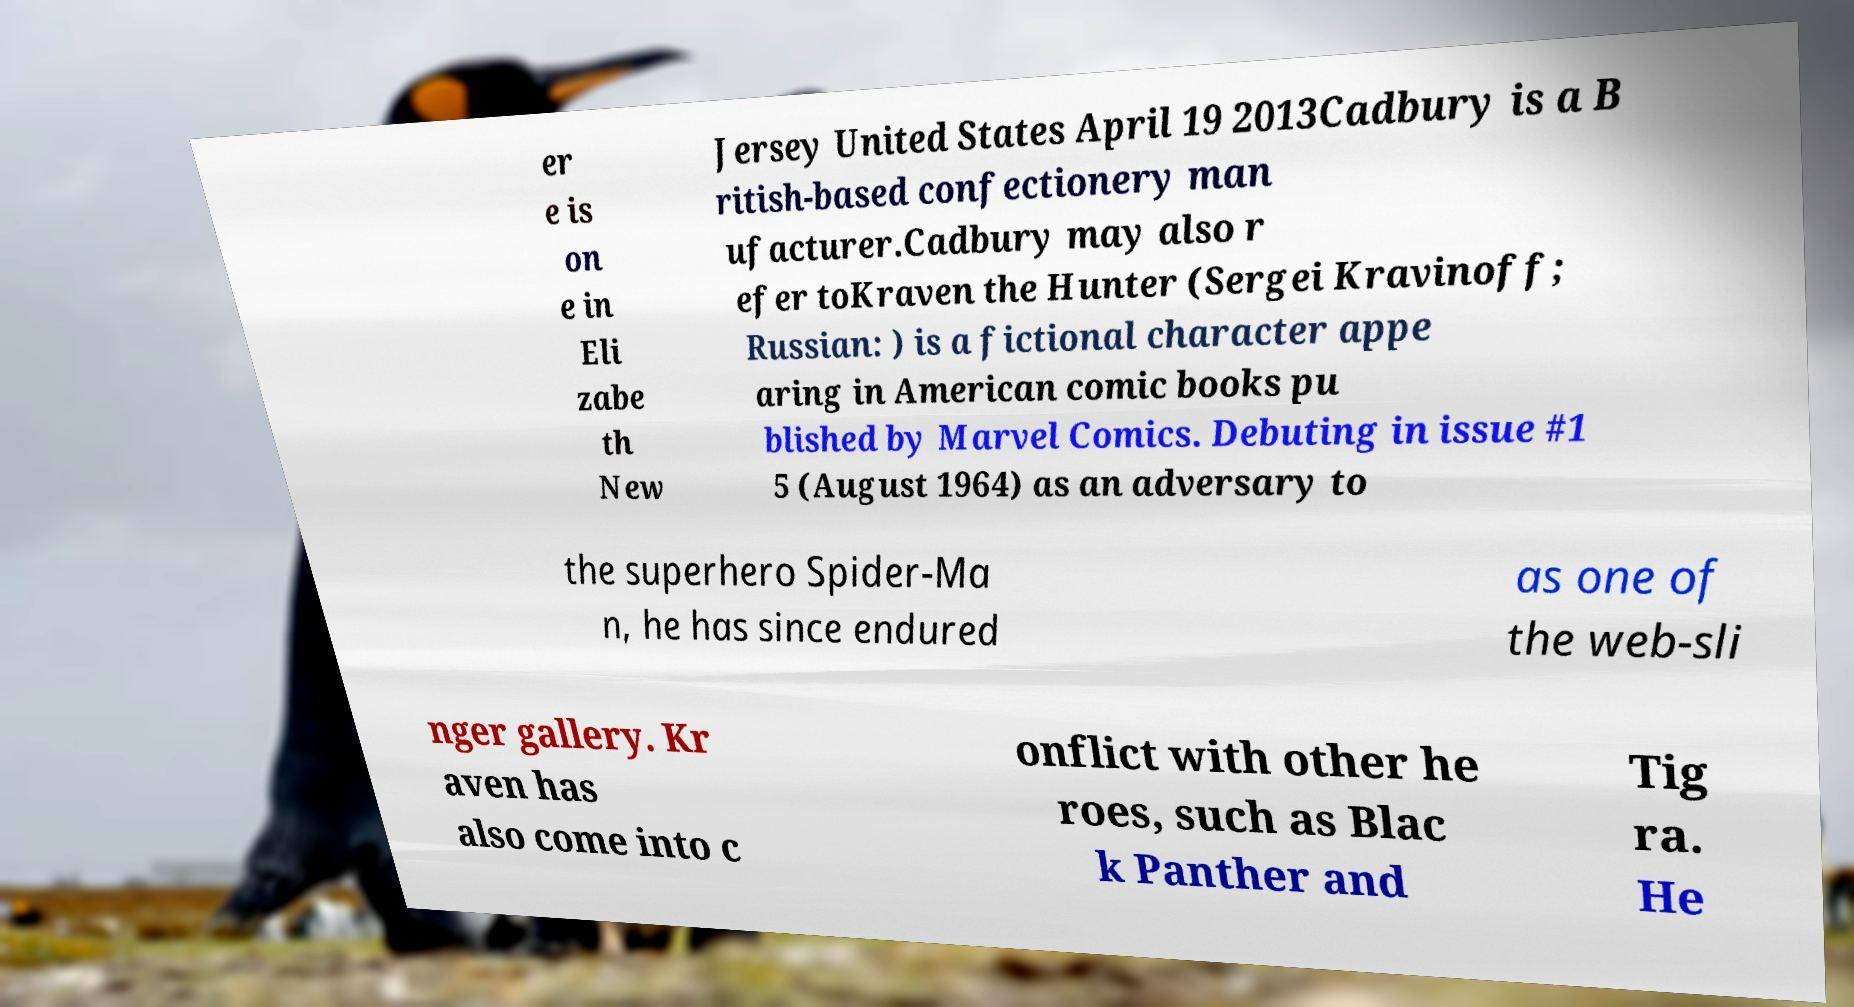Please identify and transcribe the text found in this image. er e is on e in Eli zabe th New Jersey United States April 19 2013Cadbury is a B ritish-based confectionery man ufacturer.Cadbury may also r efer toKraven the Hunter (Sergei Kravinoff; Russian: ) is a fictional character appe aring in American comic books pu blished by Marvel Comics. Debuting in issue #1 5 (August 1964) as an adversary to the superhero Spider-Ma n, he has since endured as one of the web-sli nger gallery. Kr aven has also come into c onflict with other he roes, such as Blac k Panther and Tig ra. He 